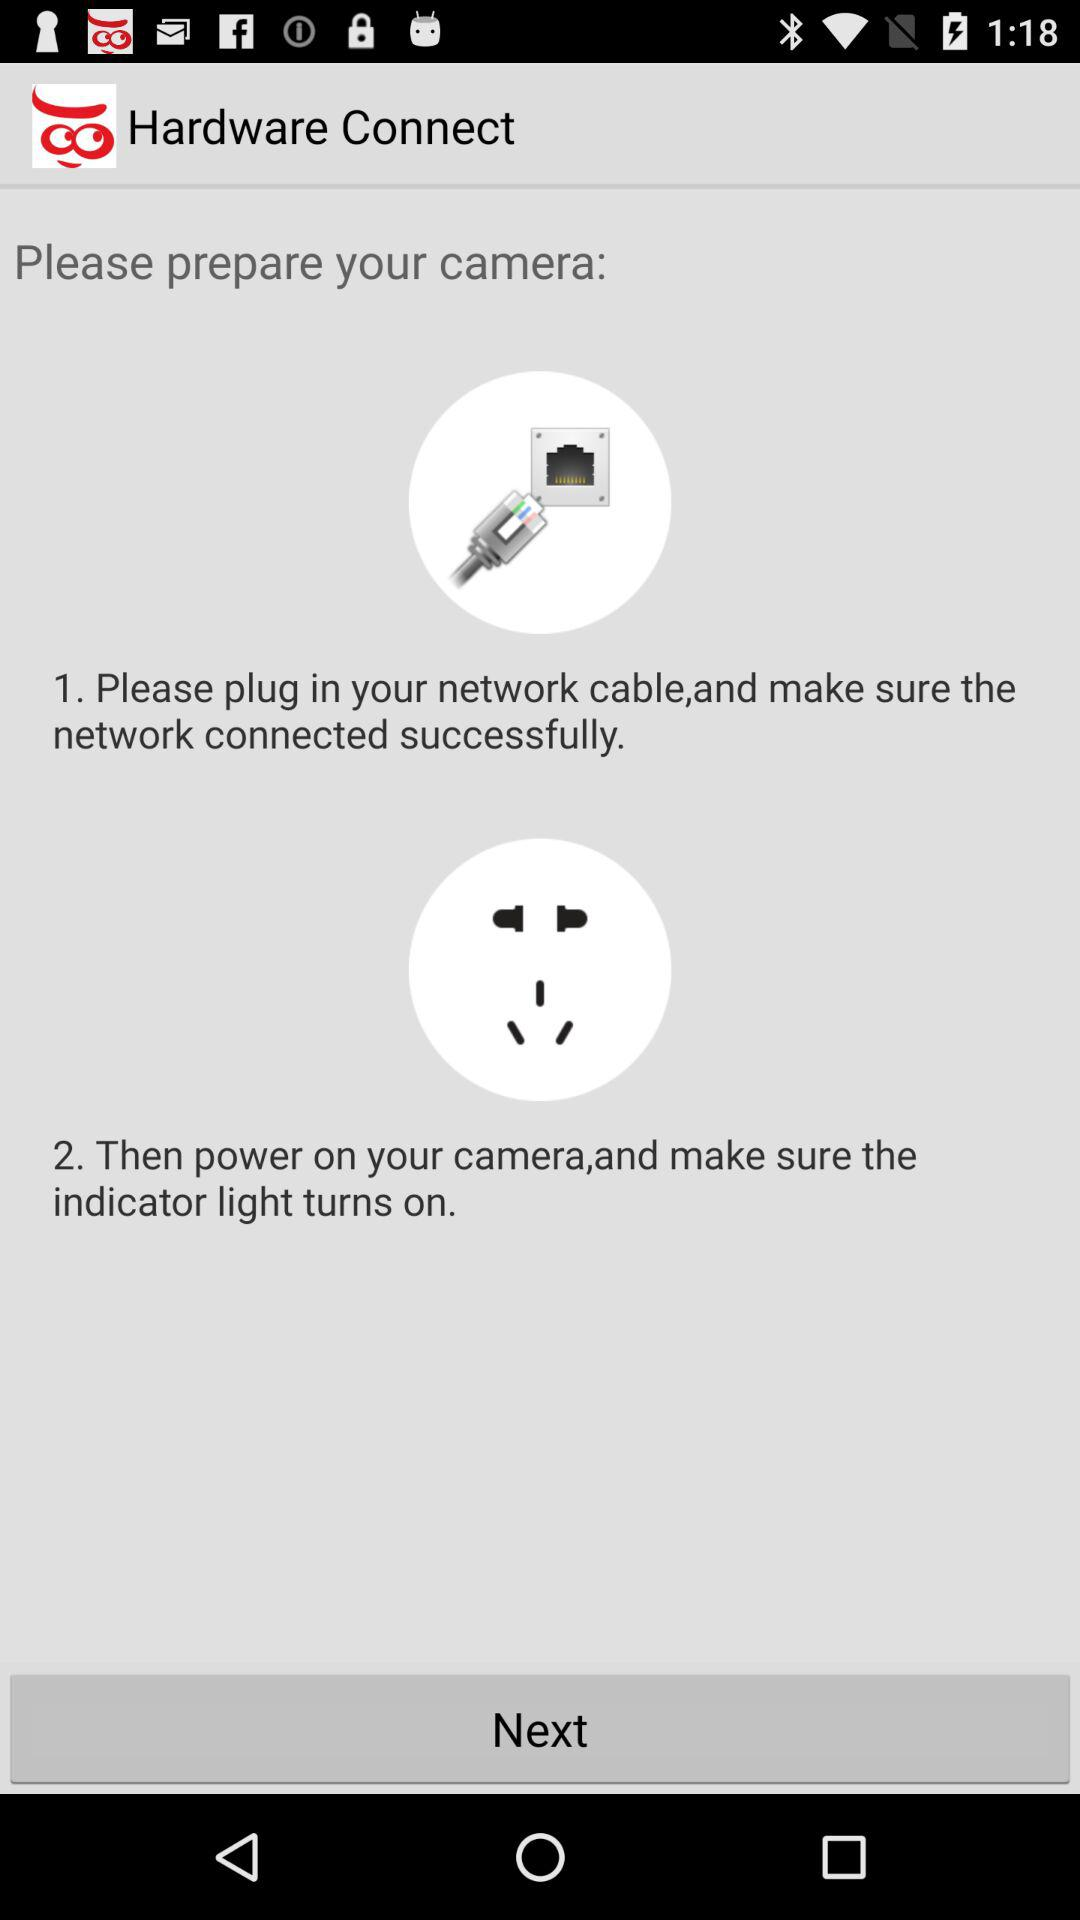What is the application name? The application name is "Hardware Connect". 